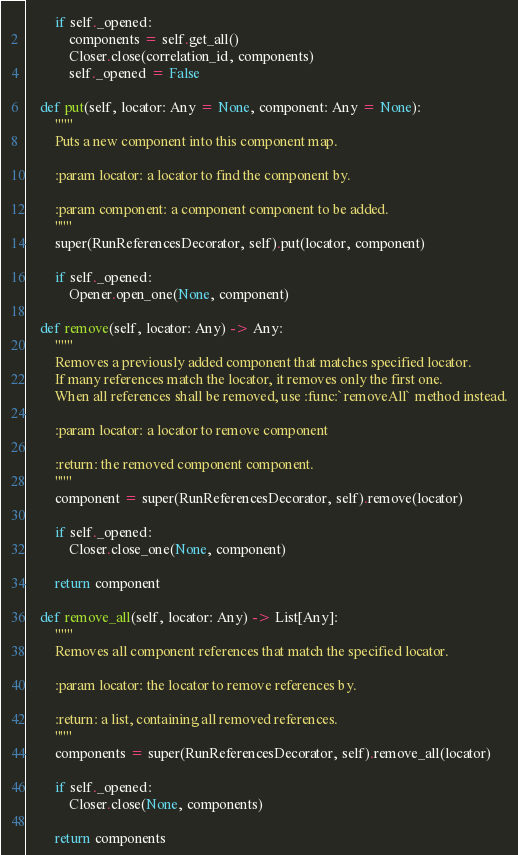Convert code to text. <code><loc_0><loc_0><loc_500><loc_500><_Python_>        if self._opened:
            components = self.get_all()
            Closer.close(correlation_id, components)
            self._opened = False

    def put(self, locator: Any = None, component: Any = None):
        """
        Puts a new component into this component map.

        :param locator: a locator to find the component by.

        :param component: a component component to be added.
        """
        super(RunReferencesDecorator, self).put(locator, component)

        if self._opened:
            Opener.open_one(None, component)

    def remove(self, locator: Any) -> Any:
        """
        Removes a previously added component that matches specified locator.
        If many references match the locator, it removes only the first one.
        When all references shall be removed, use :func:`removeAll` method instead.

        :param locator: a locator to remove component

        :return: the removed component component.
        """
        component = super(RunReferencesDecorator, self).remove(locator)

        if self._opened:
            Closer.close_one(None, component)

        return component

    def remove_all(self, locator: Any) -> List[Any]:
        """
        Removes all component references that match the specified locator.

        :param locator: the locator to remove references by.

        :return: a list, containing all removed references.
        """
        components = super(RunReferencesDecorator, self).remove_all(locator)

        if self._opened:
            Closer.close(None, components)

        return components
</code> 